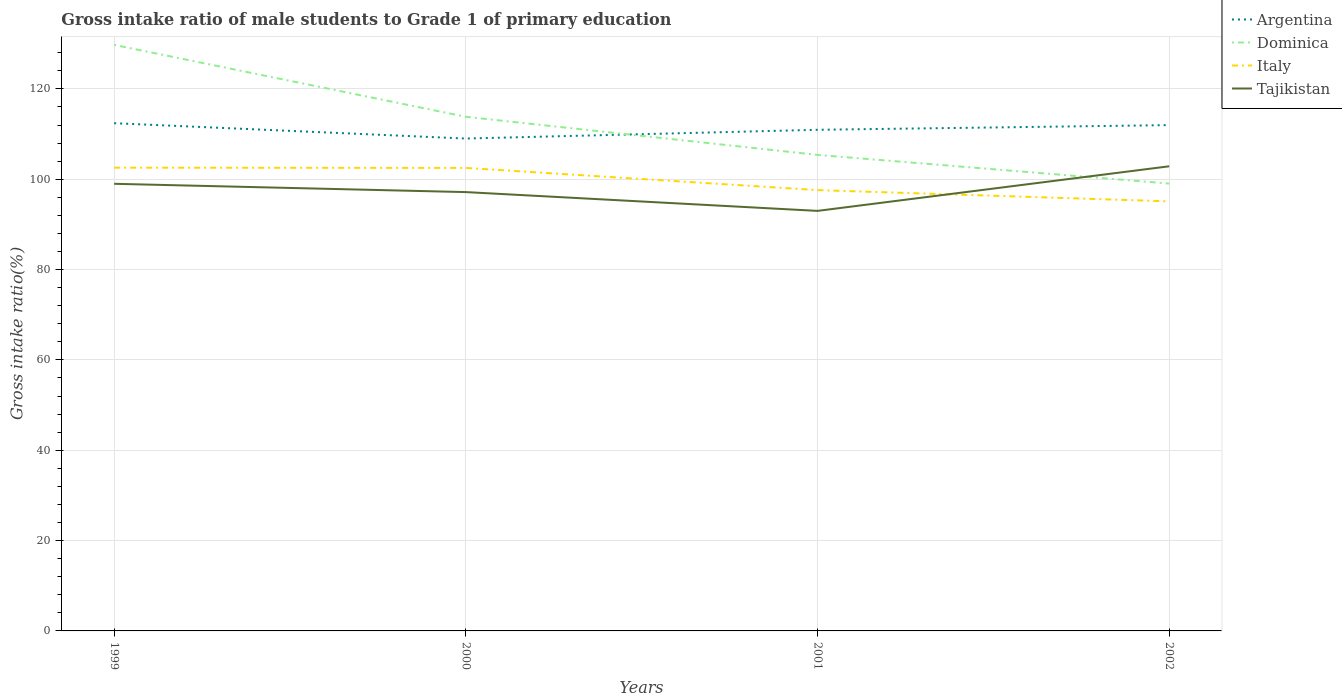Does the line corresponding to Dominica intersect with the line corresponding to Italy?
Your response must be concise. No. Across all years, what is the maximum gross intake ratio in Tajikistan?
Your answer should be compact. 92.99. In which year was the gross intake ratio in Dominica maximum?
Keep it short and to the point. 2002. What is the total gross intake ratio in Argentina in the graph?
Make the answer very short. 3.4. What is the difference between the highest and the second highest gross intake ratio in Argentina?
Your response must be concise. 3.4. How many years are there in the graph?
Make the answer very short. 4. What is the difference between two consecutive major ticks on the Y-axis?
Make the answer very short. 20. Does the graph contain any zero values?
Provide a succinct answer. No. How many legend labels are there?
Your response must be concise. 4. What is the title of the graph?
Ensure brevity in your answer.  Gross intake ratio of male students to Grade 1 of primary education. Does "Brunei Darussalam" appear as one of the legend labels in the graph?
Make the answer very short. No. What is the label or title of the X-axis?
Provide a short and direct response. Years. What is the label or title of the Y-axis?
Offer a very short reply. Gross intake ratio(%). What is the Gross intake ratio(%) in Argentina in 1999?
Your answer should be very brief. 112.41. What is the Gross intake ratio(%) of Dominica in 1999?
Your response must be concise. 129.75. What is the Gross intake ratio(%) in Italy in 1999?
Your answer should be compact. 102.56. What is the Gross intake ratio(%) of Tajikistan in 1999?
Provide a short and direct response. 98.99. What is the Gross intake ratio(%) in Argentina in 2000?
Ensure brevity in your answer.  109.01. What is the Gross intake ratio(%) of Dominica in 2000?
Offer a terse response. 113.82. What is the Gross intake ratio(%) in Italy in 2000?
Offer a very short reply. 102.51. What is the Gross intake ratio(%) of Tajikistan in 2000?
Provide a short and direct response. 97.15. What is the Gross intake ratio(%) in Argentina in 2001?
Your answer should be very brief. 110.95. What is the Gross intake ratio(%) in Dominica in 2001?
Make the answer very short. 105.39. What is the Gross intake ratio(%) in Italy in 2001?
Provide a succinct answer. 97.59. What is the Gross intake ratio(%) of Tajikistan in 2001?
Your response must be concise. 92.99. What is the Gross intake ratio(%) of Argentina in 2002?
Your answer should be very brief. 111.98. What is the Gross intake ratio(%) of Dominica in 2002?
Ensure brevity in your answer.  99.04. What is the Gross intake ratio(%) of Italy in 2002?
Your response must be concise. 95.1. What is the Gross intake ratio(%) of Tajikistan in 2002?
Make the answer very short. 102.87. Across all years, what is the maximum Gross intake ratio(%) in Argentina?
Offer a very short reply. 112.41. Across all years, what is the maximum Gross intake ratio(%) in Dominica?
Offer a terse response. 129.75. Across all years, what is the maximum Gross intake ratio(%) of Italy?
Provide a short and direct response. 102.56. Across all years, what is the maximum Gross intake ratio(%) in Tajikistan?
Your answer should be compact. 102.87. Across all years, what is the minimum Gross intake ratio(%) of Argentina?
Keep it short and to the point. 109.01. Across all years, what is the minimum Gross intake ratio(%) of Dominica?
Your answer should be compact. 99.04. Across all years, what is the minimum Gross intake ratio(%) in Italy?
Your answer should be compact. 95.1. Across all years, what is the minimum Gross intake ratio(%) of Tajikistan?
Offer a very short reply. 92.99. What is the total Gross intake ratio(%) of Argentina in the graph?
Make the answer very short. 444.35. What is the total Gross intake ratio(%) in Dominica in the graph?
Give a very brief answer. 448. What is the total Gross intake ratio(%) in Italy in the graph?
Provide a succinct answer. 397.76. What is the total Gross intake ratio(%) of Tajikistan in the graph?
Make the answer very short. 392.01. What is the difference between the Gross intake ratio(%) in Argentina in 1999 and that in 2000?
Provide a short and direct response. 3.4. What is the difference between the Gross intake ratio(%) of Dominica in 1999 and that in 2000?
Your response must be concise. 15.92. What is the difference between the Gross intake ratio(%) of Italy in 1999 and that in 2000?
Your response must be concise. 0.06. What is the difference between the Gross intake ratio(%) of Tajikistan in 1999 and that in 2000?
Provide a succinct answer. 1.84. What is the difference between the Gross intake ratio(%) in Argentina in 1999 and that in 2001?
Offer a terse response. 1.46. What is the difference between the Gross intake ratio(%) of Dominica in 1999 and that in 2001?
Provide a succinct answer. 24.36. What is the difference between the Gross intake ratio(%) of Italy in 1999 and that in 2001?
Keep it short and to the point. 4.97. What is the difference between the Gross intake ratio(%) in Tajikistan in 1999 and that in 2001?
Offer a terse response. 6. What is the difference between the Gross intake ratio(%) in Argentina in 1999 and that in 2002?
Keep it short and to the point. 0.42. What is the difference between the Gross intake ratio(%) of Dominica in 1999 and that in 2002?
Your answer should be very brief. 30.71. What is the difference between the Gross intake ratio(%) of Italy in 1999 and that in 2002?
Provide a succinct answer. 7.46. What is the difference between the Gross intake ratio(%) of Tajikistan in 1999 and that in 2002?
Your response must be concise. -3.88. What is the difference between the Gross intake ratio(%) of Argentina in 2000 and that in 2001?
Offer a very short reply. -1.94. What is the difference between the Gross intake ratio(%) in Dominica in 2000 and that in 2001?
Offer a terse response. 8.44. What is the difference between the Gross intake ratio(%) in Italy in 2000 and that in 2001?
Your answer should be very brief. 4.91. What is the difference between the Gross intake ratio(%) in Tajikistan in 2000 and that in 2001?
Offer a very short reply. 4.16. What is the difference between the Gross intake ratio(%) of Argentina in 2000 and that in 2002?
Provide a short and direct response. -2.97. What is the difference between the Gross intake ratio(%) of Dominica in 2000 and that in 2002?
Provide a short and direct response. 14.78. What is the difference between the Gross intake ratio(%) in Italy in 2000 and that in 2002?
Provide a succinct answer. 7.41. What is the difference between the Gross intake ratio(%) of Tajikistan in 2000 and that in 2002?
Give a very brief answer. -5.72. What is the difference between the Gross intake ratio(%) in Argentina in 2001 and that in 2002?
Make the answer very short. -1.03. What is the difference between the Gross intake ratio(%) in Dominica in 2001 and that in 2002?
Give a very brief answer. 6.35. What is the difference between the Gross intake ratio(%) of Italy in 2001 and that in 2002?
Offer a very short reply. 2.49. What is the difference between the Gross intake ratio(%) of Tajikistan in 2001 and that in 2002?
Your response must be concise. -9.88. What is the difference between the Gross intake ratio(%) of Argentina in 1999 and the Gross intake ratio(%) of Dominica in 2000?
Your answer should be compact. -1.42. What is the difference between the Gross intake ratio(%) of Argentina in 1999 and the Gross intake ratio(%) of Italy in 2000?
Offer a terse response. 9.9. What is the difference between the Gross intake ratio(%) in Argentina in 1999 and the Gross intake ratio(%) in Tajikistan in 2000?
Make the answer very short. 15.25. What is the difference between the Gross intake ratio(%) in Dominica in 1999 and the Gross intake ratio(%) in Italy in 2000?
Your answer should be compact. 27.24. What is the difference between the Gross intake ratio(%) in Dominica in 1999 and the Gross intake ratio(%) in Tajikistan in 2000?
Your answer should be compact. 32.59. What is the difference between the Gross intake ratio(%) of Italy in 1999 and the Gross intake ratio(%) of Tajikistan in 2000?
Your answer should be very brief. 5.41. What is the difference between the Gross intake ratio(%) of Argentina in 1999 and the Gross intake ratio(%) of Dominica in 2001?
Provide a short and direct response. 7.02. What is the difference between the Gross intake ratio(%) in Argentina in 1999 and the Gross intake ratio(%) in Italy in 2001?
Your answer should be compact. 14.81. What is the difference between the Gross intake ratio(%) of Argentina in 1999 and the Gross intake ratio(%) of Tajikistan in 2001?
Offer a terse response. 19.41. What is the difference between the Gross intake ratio(%) of Dominica in 1999 and the Gross intake ratio(%) of Italy in 2001?
Your answer should be very brief. 32.15. What is the difference between the Gross intake ratio(%) of Dominica in 1999 and the Gross intake ratio(%) of Tajikistan in 2001?
Your answer should be compact. 36.75. What is the difference between the Gross intake ratio(%) of Italy in 1999 and the Gross intake ratio(%) of Tajikistan in 2001?
Your answer should be compact. 9.57. What is the difference between the Gross intake ratio(%) of Argentina in 1999 and the Gross intake ratio(%) of Dominica in 2002?
Provide a succinct answer. 13.37. What is the difference between the Gross intake ratio(%) in Argentina in 1999 and the Gross intake ratio(%) in Italy in 2002?
Ensure brevity in your answer.  17.31. What is the difference between the Gross intake ratio(%) of Argentina in 1999 and the Gross intake ratio(%) of Tajikistan in 2002?
Provide a short and direct response. 9.54. What is the difference between the Gross intake ratio(%) in Dominica in 1999 and the Gross intake ratio(%) in Italy in 2002?
Provide a succinct answer. 34.65. What is the difference between the Gross intake ratio(%) of Dominica in 1999 and the Gross intake ratio(%) of Tajikistan in 2002?
Provide a succinct answer. 26.88. What is the difference between the Gross intake ratio(%) of Italy in 1999 and the Gross intake ratio(%) of Tajikistan in 2002?
Give a very brief answer. -0.31. What is the difference between the Gross intake ratio(%) in Argentina in 2000 and the Gross intake ratio(%) in Dominica in 2001?
Your answer should be compact. 3.62. What is the difference between the Gross intake ratio(%) in Argentina in 2000 and the Gross intake ratio(%) in Italy in 2001?
Offer a very short reply. 11.42. What is the difference between the Gross intake ratio(%) of Argentina in 2000 and the Gross intake ratio(%) of Tajikistan in 2001?
Your response must be concise. 16.02. What is the difference between the Gross intake ratio(%) of Dominica in 2000 and the Gross intake ratio(%) of Italy in 2001?
Make the answer very short. 16.23. What is the difference between the Gross intake ratio(%) of Dominica in 2000 and the Gross intake ratio(%) of Tajikistan in 2001?
Provide a succinct answer. 20.83. What is the difference between the Gross intake ratio(%) of Italy in 2000 and the Gross intake ratio(%) of Tajikistan in 2001?
Keep it short and to the point. 9.51. What is the difference between the Gross intake ratio(%) of Argentina in 2000 and the Gross intake ratio(%) of Dominica in 2002?
Give a very brief answer. 9.97. What is the difference between the Gross intake ratio(%) in Argentina in 2000 and the Gross intake ratio(%) in Italy in 2002?
Give a very brief answer. 13.91. What is the difference between the Gross intake ratio(%) in Argentina in 2000 and the Gross intake ratio(%) in Tajikistan in 2002?
Ensure brevity in your answer.  6.14. What is the difference between the Gross intake ratio(%) of Dominica in 2000 and the Gross intake ratio(%) of Italy in 2002?
Offer a terse response. 18.72. What is the difference between the Gross intake ratio(%) of Dominica in 2000 and the Gross intake ratio(%) of Tajikistan in 2002?
Your answer should be very brief. 10.95. What is the difference between the Gross intake ratio(%) of Italy in 2000 and the Gross intake ratio(%) of Tajikistan in 2002?
Make the answer very short. -0.36. What is the difference between the Gross intake ratio(%) of Argentina in 2001 and the Gross intake ratio(%) of Dominica in 2002?
Your answer should be very brief. 11.91. What is the difference between the Gross intake ratio(%) of Argentina in 2001 and the Gross intake ratio(%) of Italy in 2002?
Provide a short and direct response. 15.85. What is the difference between the Gross intake ratio(%) in Argentina in 2001 and the Gross intake ratio(%) in Tajikistan in 2002?
Offer a terse response. 8.08. What is the difference between the Gross intake ratio(%) in Dominica in 2001 and the Gross intake ratio(%) in Italy in 2002?
Provide a succinct answer. 10.29. What is the difference between the Gross intake ratio(%) of Dominica in 2001 and the Gross intake ratio(%) of Tajikistan in 2002?
Your response must be concise. 2.52. What is the difference between the Gross intake ratio(%) of Italy in 2001 and the Gross intake ratio(%) of Tajikistan in 2002?
Keep it short and to the point. -5.28. What is the average Gross intake ratio(%) of Argentina per year?
Provide a short and direct response. 111.09. What is the average Gross intake ratio(%) in Dominica per year?
Provide a succinct answer. 112. What is the average Gross intake ratio(%) in Italy per year?
Your answer should be compact. 99.44. What is the average Gross intake ratio(%) in Tajikistan per year?
Give a very brief answer. 98. In the year 1999, what is the difference between the Gross intake ratio(%) in Argentina and Gross intake ratio(%) in Dominica?
Make the answer very short. -17.34. In the year 1999, what is the difference between the Gross intake ratio(%) of Argentina and Gross intake ratio(%) of Italy?
Your answer should be compact. 9.84. In the year 1999, what is the difference between the Gross intake ratio(%) of Argentina and Gross intake ratio(%) of Tajikistan?
Ensure brevity in your answer.  13.41. In the year 1999, what is the difference between the Gross intake ratio(%) in Dominica and Gross intake ratio(%) in Italy?
Your response must be concise. 27.18. In the year 1999, what is the difference between the Gross intake ratio(%) in Dominica and Gross intake ratio(%) in Tajikistan?
Offer a terse response. 30.76. In the year 1999, what is the difference between the Gross intake ratio(%) of Italy and Gross intake ratio(%) of Tajikistan?
Make the answer very short. 3.57. In the year 2000, what is the difference between the Gross intake ratio(%) of Argentina and Gross intake ratio(%) of Dominica?
Your response must be concise. -4.82. In the year 2000, what is the difference between the Gross intake ratio(%) in Argentina and Gross intake ratio(%) in Italy?
Keep it short and to the point. 6.5. In the year 2000, what is the difference between the Gross intake ratio(%) in Argentina and Gross intake ratio(%) in Tajikistan?
Ensure brevity in your answer.  11.85. In the year 2000, what is the difference between the Gross intake ratio(%) of Dominica and Gross intake ratio(%) of Italy?
Make the answer very short. 11.32. In the year 2000, what is the difference between the Gross intake ratio(%) in Dominica and Gross intake ratio(%) in Tajikistan?
Provide a succinct answer. 16.67. In the year 2000, what is the difference between the Gross intake ratio(%) of Italy and Gross intake ratio(%) of Tajikistan?
Your answer should be very brief. 5.35. In the year 2001, what is the difference between the Gross intake ratio(%) of Argentina and Gross intake ratio(%) of Dominica?
Keep it short and to the point. 5.56. In the year 2001, what is the difference between the Gross intake ratio(%) of Argentina and Gross intake ratio(%) of Italy?
Your answer should be compact. 13.36. In the year 2001, what is the difference between the Gross intake ratio(%) in Argentina and Gross intake ratio(%) in Tajikistan?
Your answer should be compact. 17.95. In the year 2001, what is the difference between the Gross intake ratio(%) of Dominica and Gross intake ratio(%) of Italy?
Make the answer very short. 7.79. In the year 2001, what is the difference between the Gross intake ratio(%) in Dominica and Gross intake ratio(%) in Tajikistan?
Keep it short and to the point. 12.39. In the year 2001, what is the difference between the Gross intake ratio(%) of Italy and Gross intake ratio(%) of Tajikistan?
Keep it short and to the point. 4.6. In the year 2002, what is the difference between the Gross intake ratio(%) in Argentina and Gross intake ratio(%) in Dominica?
Your response must be concise. 12.94. In the year 2002, what is the difference between the Gross intake ratio(%) of Argentina and Gross intake ratio(%) of Italy?
Ensure brevity in your answer.  16.88. In the year 2002, what is the difference between the Gross intake ratio(%) of Argentina and Gross intake ratio(%) of Tajikistan?
Your answer should be very brief. 9.11. In the year 2002, what is the difference between the Gross intake ratio(%) in Dominica and Gross intake ratio(%) in Italy?
Your response must be concise. 3.94. In the year 2002, what is the difference between the Gross intake ratio(%) of Dominica and Gross intake ratio(%) of Tajikistan?
Provide a short and direct response. -3.83. In the year 2002, what is the difference between the Gross intake ratio(%) of Italy and Gross intake ratio(%) of Tajikistan?
Your answer should be compact. -7.77. What is the ratio of the Gross intake ratio(%) in Argentina in 1999 to that in 2000?
Ensure brevity in your answer.  1.03. What is the ratio of the Gross intake ratio(%) of Dominica in 1999 to that in 2000?
Offer a very short reply. 1.14. What is the ratio of the Gross intake ratio(%) in Tajikistan in 1999 to that in 2000?
Offer a very short reply. 1.02. What is the ratio of the Gross intake ratio(%) in Argentina in 1999 to that in 2001?
Ensure brevity in your answer.  1.01. What is the ratio of the Gross intake ratio(%) in Dominica in 1999 to that in 2001?
Make the answer very short. 1.23. What is the ratio of the Gross intake ratio(%) in Italy in 1999 to that in 2001?
Offer a terse response. 1.05. What is the ratio of the Gross intake ratio(%) of Tajikistan in 1999 to that in 2001?
Give a very brief answer. 1.06. What is the ratio of the Gross intake ratio(%) in Dominica in 1999 to that in 2002?
Offer a very short reply. 1.31. What is the ratio of the Gross intake ratio(%) of Italy in 1999 to that in 2002?
Keep it short and to the point. 1.08. What is the ratio of the Gross intake ratio(%) of Tajikistan in 1999 to that in 2002?
Make the answer very short. 0.96. What is the ratio of the Gross intake ratio(%) in Argentina in 2000 to that in 2001?
Ensure brevity in your answer.  0.98. What is the ratio of the Gross intake ratio(%) in Dominica in 2000 to that in 2001?
Provide a short and direct response. 1.08. What is the ratio of the Gross intake ratio(%) of Italy in 2000 to that in 2001?
Ensure brevity in your answer.  1.05. What is the ratio of the Gross intake ratio(%) in Tajikistan in 2000 to that in 2001?
Provide a succinct answer. 1.04. What is the ratio of the Gross intake ratio(%) in Argentina in 2000 to that in 2002?
Give a very brief answer. 0.97. What is the ratio of the Gross intake ratio(%) in Dominica in 2000 to that in 2002?
Ensure brevity in your answer.  1.15. What is the ratio of the Gross intake ratio(%) of Italy in 2000 to that in 2002?
Your response must be concise. 1.08. What is the ratio of the Gross intake ratio(%) of Dominica in 2001 to that in 2002?
Give a very brief answer. 1.06. What is the ratio of the Gross intake ratio(%) of Italy in 2001 to that in 2002?
Make the answer very short. 1.03. What is the ratio of the Gross intake ratio(%) in Tajikistan in 2001 to that in 2002?
Ensure brevity in your answer.  0.9. What is the difference between the highest and the second highest Gross intake ratio(%) in Argentina?
Provide a succinct answer. 0.42. What is the difference between the highest and the second highest Gross intake ratio(%) of Dominica?
Your answer should be very brief. 15.92. What is the difference between the highest and the second highest Gross intake ratio(%) of Italy?
Provide a succinct answer. 0.06. What is the difference between the highest and the second highest Gross intake ratio(%) of Tajikistan?
Offer a terse response. 3.88. What is the difference between the highest and the lowest Gross intake ratio(%) of Argentina?
Ensure brevity in your answer.  3.4. What is the difference between the highest and the lowest Gross intake ratio(%) of Dominica?
Provide a succinct answer. 30.71. What is the difference between the highest and the lowest Gross intake ratio(%) of Italy?
Provide a succinct answer. 7.46. What is the difference between the highest and the lowest Gross intake ratio(%) in Tajikistan?
Provide a succinct answer. 9.88. 